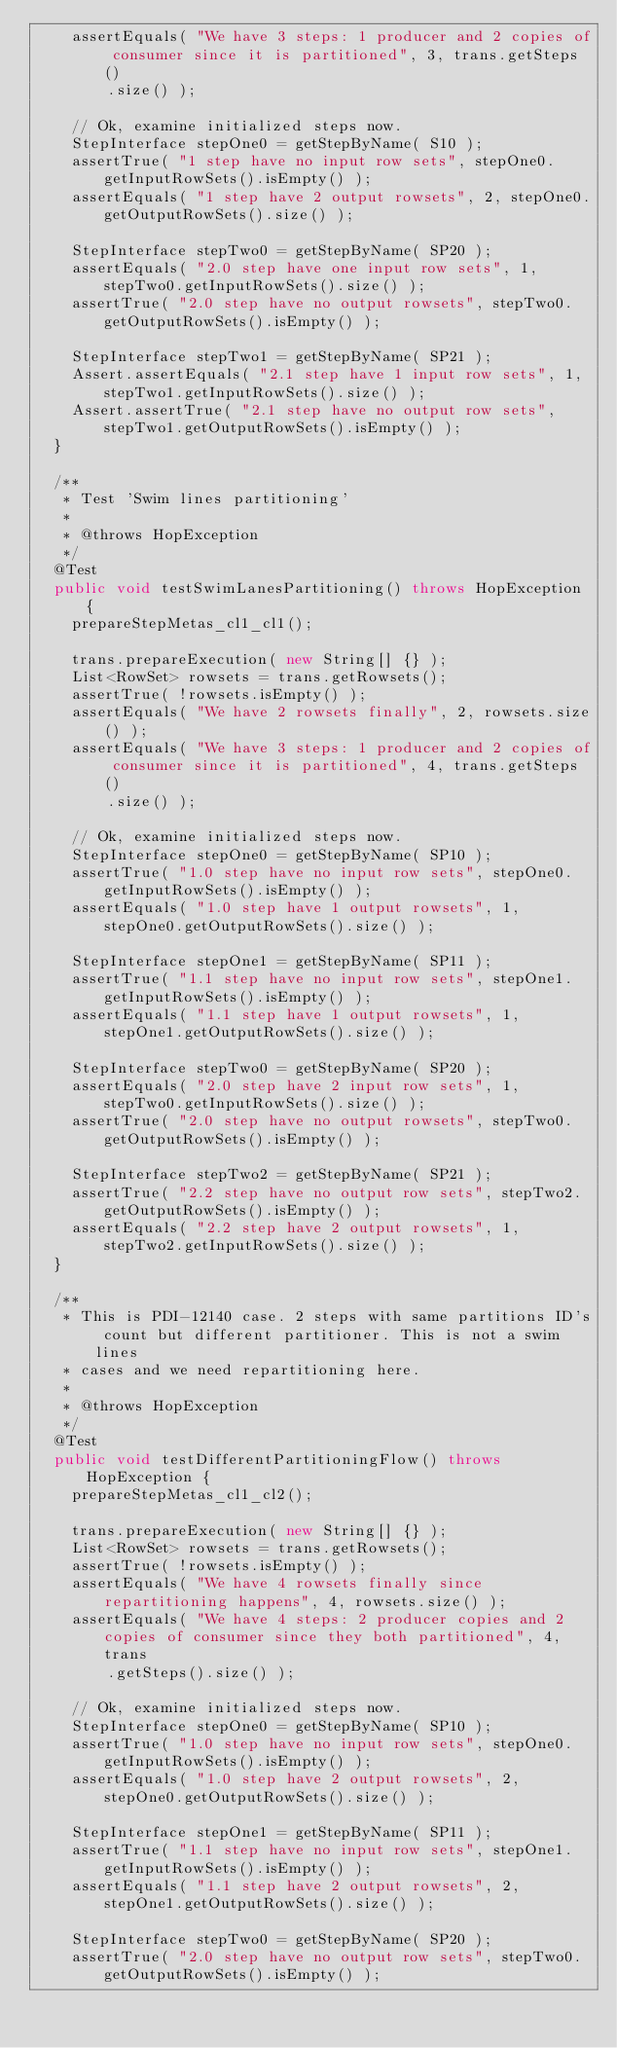Convert code to text. <code><loc_0><loc_0><loc_500><loc_500><_Java_>    assertEquals( "We have 3 steps: 1 producer and 2 copies of consumer since it is partitioned", 3, trans.getSteps()
        .size() );

    // Ok, examine initialized steps now.
    StepInterface stepOne0 = getStepByName( S10 );
    assertTrue( "1 step have no input row sets", stepOne0.getInputRowSets().isEmpty() );
    assertEquals( "1 step have 2 output rowsets", 2, stepOne0.getOutputRowSets().size() );

    StepInterface stepTwo0 = getStepByName( SP20 );
    assertEquals( "2.0 step have one input row sets", 1, stepTwo0.getInputRowSets().size() );
    assertTrue( "2.0 step have no output rowsets", stepTwo0.getOutputRowSets().isEmpty() );

    StepInterface stepTwo1 = getStepByName( SP21 );
    Assert.assertEquals( "2.1 step have 1 input row sets", 1, stepTwo1.getInputRowSets().size() );
    Assert.assertTrue( "2.1 step have no output row sets", stepTwo1.getOutputRowSets().isEmpty() );
  }

  /**
   * Test 'Swim lines partitioning'
   * 
   * @throws HopException
   */
  @Test
  public void testSwimLanesPartitioning() throws HopException {
    prepareStepMetas_cl1_cl1();

    trans.prepareExecution( new String[] {} );
    List<RowSet> rowsets = trans.getRowsets();
    assertTrue( !rowsets.isEmpty() );
    assertEquals( "We have 2 rowsets finally", 2, rowsets.size() );
    assertEquals( "We have 3 steps: 1 producer and 2 copies of consumer since it is partitioned", 4, trans.getSteps()
        .size() );

    // Ok, examine initialized steps now.
    StepInterface stepOne0 = getStepByName( SP10 );
    assertTrue( "1.0 step have no input row sets", stepOne0.getInputRowSets().isEmpty() );
    assertEquals( "1.0 step have 1 output rowsets", 1, stepOne0.getOutputRowSets().size() );

    StepInterface stepOne1 = getStepByName( SP11 );
    assertTrue( "1.1 step have no input row sets", stepOne1.getInputRowSets().isEmpty() );
    assertEquals( "1.1 step have 1 output rowsets", 1, stepOne1.getOutputRowSets().size() );

    StepInterface stepTwo0 = getStepByName( SP20 );
    assertEquals( "2.0 step have 2 input row sets", 1, stepTwo0.getInputRowSets().size() );
    assertTrue( "2.0 step have no output rowsets", stepTwo0.getOutputRowSets().isEmpty() );

    StepInterface stepTwo2 = getStepByName( SP21 );
    assertTrue( "2.2 step have no output row sets", stepTwo2.getOutputRowSets().isEmpty() );
    assertEquals( "2.2 step have 2 output rowsets", 1, stepTwo2.getInputRowSets().size() );
  }

  /**
   * This is PDI-12140 case. 2 steps with same partitions ID's count but different partitioner. This is not a swim lines
   * cases and we need repartitioning here.
   * 
   * @throws HopException
   */
  @Test
  public void testDifferentPartitioningFlow() throws HopException {
    prepareStepMetas_cl1_cl2();

    trans.prepareExecution( new String[] {} );
    List<RowSet> rowsets = trans.getRowsets();
    assertTrue( !rowsets.isEmpty() );
    assertEquals( "We have 4 rowsets finally since repartitioning happens", 4, rowsets.size() );
    assertEquals( "We have 4 steps: 2 producer copies and 2 copies of consumer since they both partitioned", 4, trans
        .getSteps().size() );

    // Ok, examine initialized steps now.
    StepInterface stepOne0 = getStepByName( SP10 );
    assertTrue( "1.0 step have no input row sets", stepOne0.getInputRowSets().isEmpty() );
    assertEquals( "1.0 step have 2 output rowsets", 2, stepOne0.getOutputRowSets().size() );

    StepInterface stepOne1 = getStepByName( SP11 );
    assertTrue( "1.1 step have no input row sets", stepOne1.getInputRowSets().isEmpty() );
    assertEquals( "1.1 step have 2 output rowsets", 2, stepOne1.getOutputRowSets().size() );

    StepInterface stepTwo0 = getStepByName( SP20 );
    assertTrue( "2.0 step have no output row sets", stepTwo0.getOutputRowSets().isEmpty() );</code> 